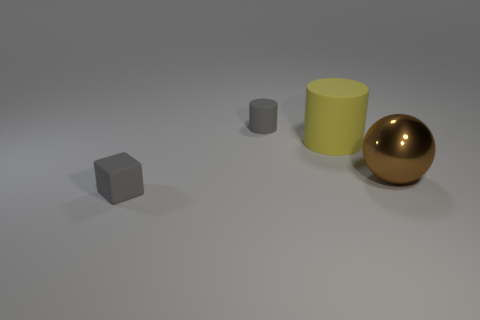What can you infer about the position of the objects in relation to each other? The objects are arranged with a sense of increasing size from left to right, with the small gray cube being the farthest to the left and the golden sphere farthest to the right. 